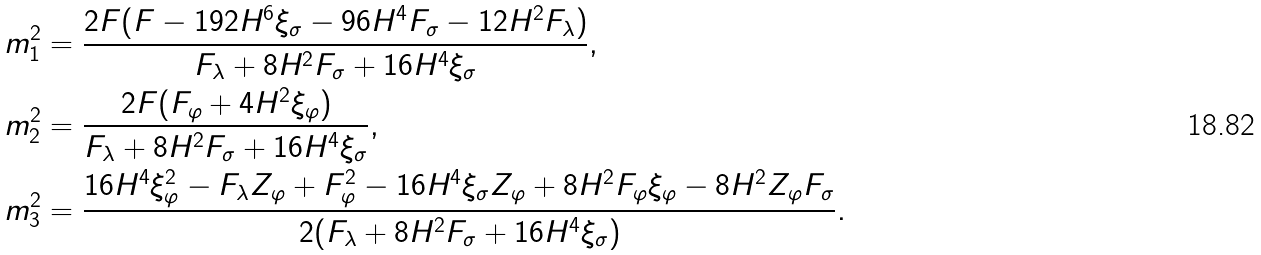<formula> <loc_0><loc_0><loc_500><loc_500>m _ { 1 } ^ { 2 } & = \frac { 2 F ( F - 1 9 2 H ^ { 6 } \xi _ { \sigma } - 9 6 H ^ { 4 } F _ { \sigma } - 1 2 H ^ { 2 } F _ { \lambda } ) } { F _ { \lambda } + 8 H ^ { 2 } F _ { \sigma } + 1 6 H ^ { 4 } \xi _ { \sigma } } , \\ m _ { 2 } ^ { 2 } & = \frac { 2 F ( F _ { \varphi } + 4 H ^ { 2 } \xi _ { \varphi } ) } { F _ { \lambda } + 8 H ^ { 2 } F _ { \sigma } + 1 6 H ^ { 4 } \xi _ { \sigma } } , \\ m _ { 3 } ^ { 2 } & = \frac { 1 6 H ^ { 4 } \xi _ { \varphi } ^ { 2 } - F _ { \lambda } Z _ { \varphi } + F _ { \varphi } ^ { 2 } - 1 6 H ^ { 4 } \xi _ { \sigma } Z _ { \varphi } + 8 H ^ { 2 } F _ { \varphi } \xi _ { \varphi } - 8 H ^ { 2 } Z _ { \varphi } F _ { \sigma } } { 2 ( F _ { \lambda } + 8 H ^ { 2 } F _ { \sigma } + 1 6 H ^ { 4 } \xi _ { \sigma } ) } .</formula> 